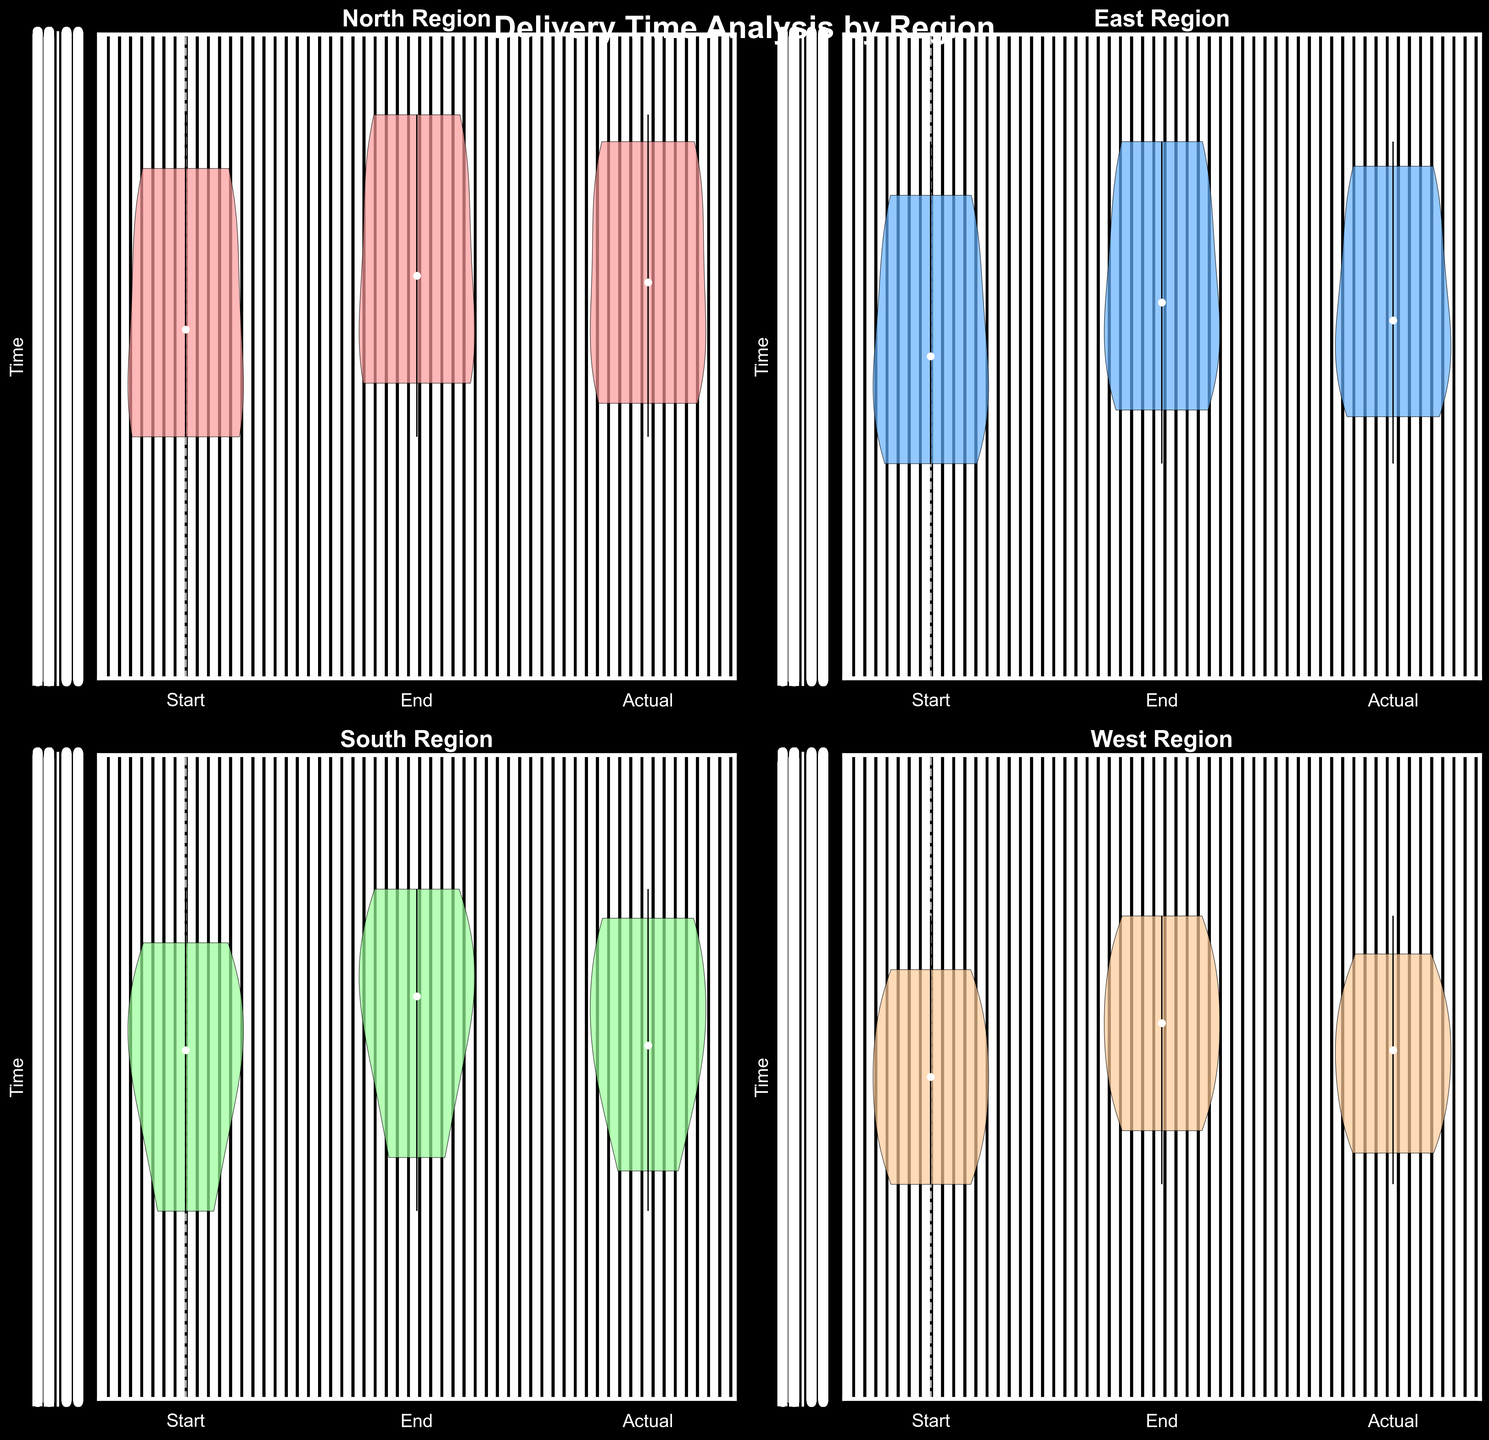What's the title of the figure? The title is displayed at the top center of the figure, just above the subplots. The large text reads "Delivery Time Analysis by Region".
Answer: Delivery Time Analysis by Region What do the colors in the violin charts represent? The colors help differentiate between the regions within the subplots. Each subplot uses a distinct color: pink, blue, green, and beige, indicating different regions.
Answer: Different regions What regions are compared in the figure? Each subplot is labeled with a region at the top. The regions are North, East, South, and West.
Answer: North, East, South, West Which data points have the highest range of variation in the North region? In the subplot for the North region, the actual delivery times have the widest distribution, suggesting a higher range of variation. This can be observed by the spread-out shape of the violin plot for the 'Actual' points.
Answer: Actual delivery times What is common between the promised end times and actual delivery times in the East region? Observing the subplot for the East region, we see that the medians for both the 'Promised End' and 'Actual' delivery times appear closely aligned, indicated by the white dots.
Answer: Closely aligned medians In the West region, are actual delivery times generally earlier or later than the promised time windows? In the West region's subplot, the median of the actual delivery times (white dot) is generally situated earlier (lower y-axis value) than the medians of both the promised start and end times.
Answer: Earlier How do the promised start times compare across the North and South regions? By comparing the subplots for North and South regions, the promised start times in the North have a wider spread, whereas in the South, it appears more concentrated towards earlier times of the day.
Answer: North has wider spread; South is earlier What is the overall trend observed for the actual delivery times across all regions? Across all subplots, actual delivery times tend to cluster within the promised time windows but show varying degrees of lateness or earliness, indicating region-specific delivery efficiency differences.
Answer: Cluster within promised windows Which region appears to have the highest consistency in delivery times compared to the promised windows? The subplot for the East region indicates the highest consistency as the shapes of the violin plots for 'Promised Start', 'Promised End', and 'Actual' delivery times are closer together, with minimal spread.
Answer: East 